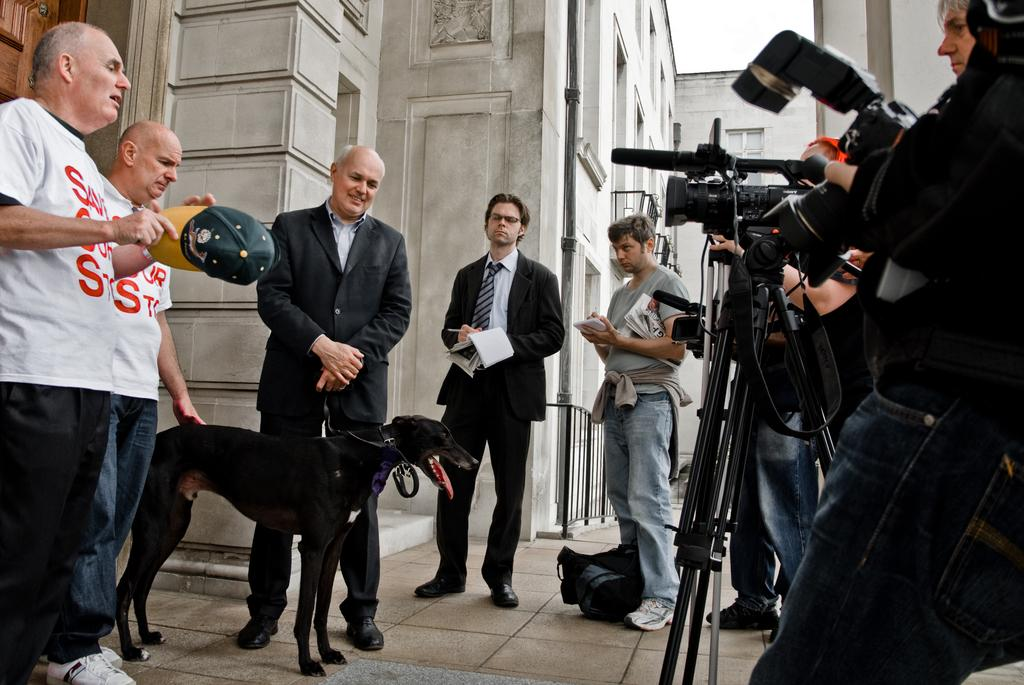What is the main subject of the image? The main subject of the image is a group of people. What are the people doing in the image? The group of people is standing around a dog. Are there any objects related to photography in the image? Yes, two people are holding cameras with stands. What level of water can be seen in the image in the image? There is no water present in the image; it features a group of people standing around a dog and holding cameras with stands. What type of watch is the dog wearing in the image? Dogs do not wear watches, and there is no watch visible in the image. 